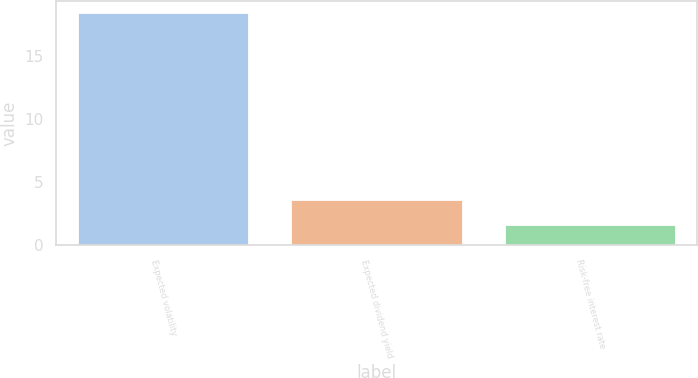Convert chart. <chart><loc_0><loc_0><loc_500><loc_500><bar_chart><fcel>Expected volatility<fcel>Expected dividend yield<fcel>Risk-free interest rate<nl><fcel>18.4<fcel>3.6<fcel>1.6<nl></chart> 